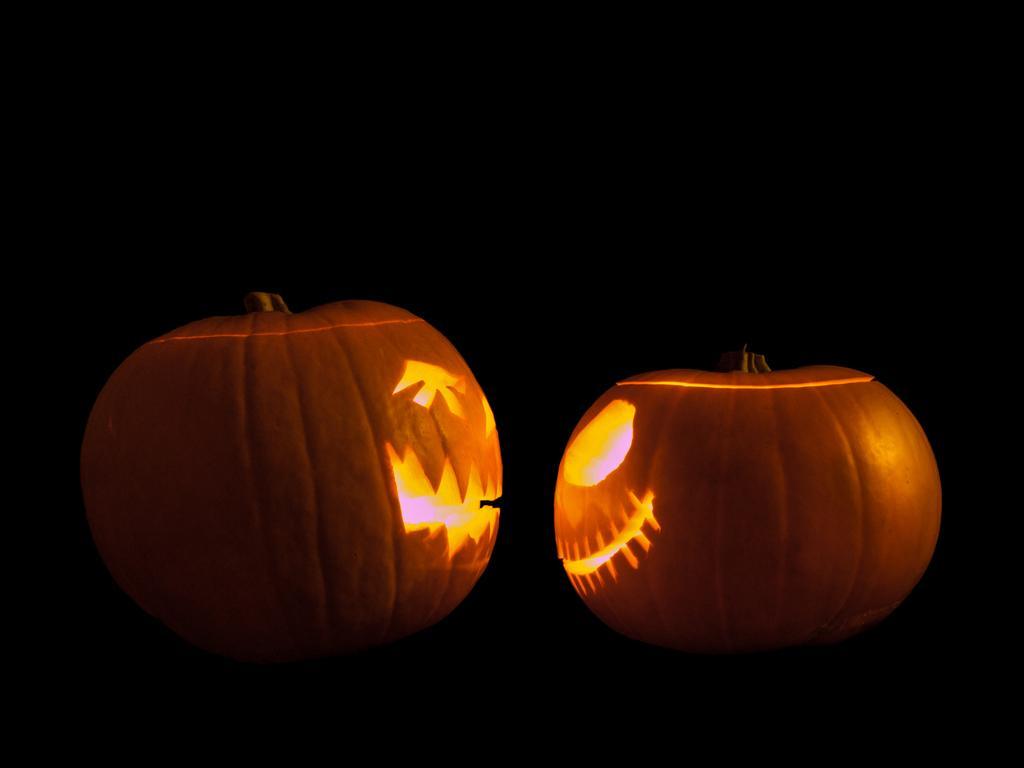Can you describe this image briefly? In this picture we can see couple of pumpkins and dark background. 